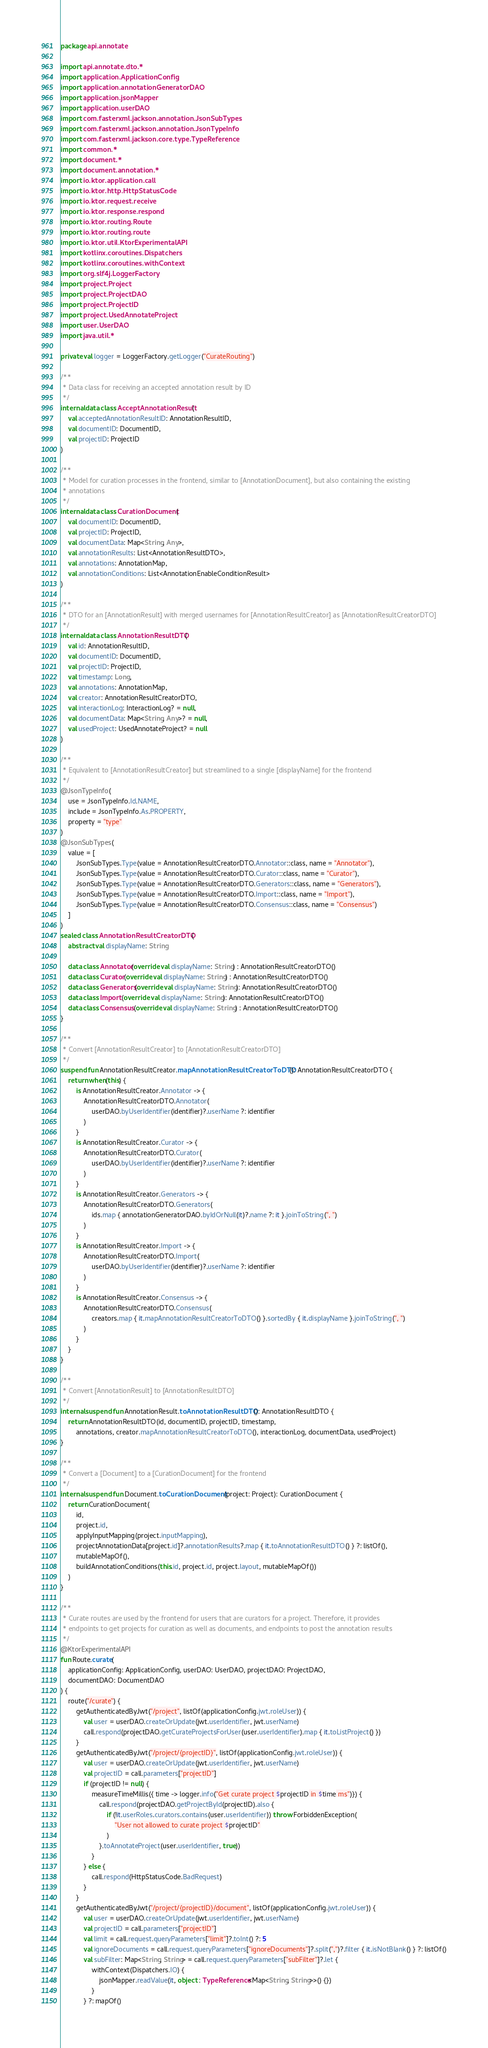<code> <loc_0><loc_0><loc_500><loc_500><_Kotlin_>package api.annotate

import api.annotate.dto.*
import application.ApplicationConfig
import application.annotationGeneratorDAO
import application.jsonMapper
import application.userDAO
import com.fasterxml.jackson.annotation.JsonSubTypes
import com.fasterxml.jackson.annotation.JsonTypeInfo
import com.fasterxml.jackson.core.type.TypeReference
import common.*
import document.*
import document.annotation.*
import io.ktor.application.call
import io.ktor.http.HttpStatusCode
import io.ktor.request.receive
import io.ktor.response.respond
import io.ktor.routing.Route
import io.ktor.routing.route
import io.ktor.util.KtorExperimentalAPI
import kotlinx.coroutines.Dispatchers
import kotlinx.coroutines.withContext
import org.slf4j.LoggerFactory
import project.Project
import project.ProjectDAO
import project.ProjectID
import project.UsedAnnotateProject
import user.UserDAO
import java.util.*

private val logger = LoggerFactory.getLogger("CurateRouting")

/**
 * Data class for receiving an accepted annotation result by ID
 */
internal data class AcceptAnnotationResult(
    val acceptedAnnotationResultID: AnnotationResultID,
    val documentID: DocumentID,
    val projectID: ProjectID
)

/**
 * Model for curation processes in the frontend, similar to [AnnotationDocument], but also containing the existing
 * annotations
 */
internal data class CurationDocument(
    val documentID: DocumentID,
    val projectID: ProjectID,
    val documentData: Map<String, Any>,
    val annotationResults: List<AnnotationResultDTO>,
    val annotations: AnnotationMap,
    val annotationConditions: List<AnnotationEnableConditionResult>
)

/**
 * DTO for an [AnnotationResult] with merged usernames for [AnnotationResultCreator] as [AnnotationResultCreatorDTO]
 */
internal data class AnnotationResultDTO(
    val id: AnnotationResultID,
    val documentID: DocumentID,
    val projectID: ProjectID,
    val timestamp: Long,
    val annotations: AnnotationMap,
    val creator: AnnotationResultCreatorDTO,
    val interactionLog: InteractionLog? = null,
    val documentData: Map<String, Any>? = null,
    val usedProject: UsedAnnotateProject? = null
)

/**
 * Equivalent to [AnnotationResultCreator] but streamlined to a single [displayName] for the frontend
 */
@JsonTypeInfo(
    use = JsonTypeInfo.Id.NAME,
    include = JsonTypeInfo.As.PROPERTY,
    property = "type"
)
@JsonSubTypes(
    value = [
        JsonSubTypes.Type(value = AnnotationResultCreatorDTO.Annotator::class, name = "Annotator"),
        JsonSubTypes.Type(value = AnnotationResultCreatorDTO.Curator::class, name = "Curator"),
        JsonSubTypes.Type(value = AnnotationResultCreatorDTO.Generators::class, name = "Generators"),
        JsonSubTypes.Type(value = AnnotationResultCreatorDTO.Import::class, name = "Import"),
        JsonSubTypes.Type(value = AnnotationResultCreatorDTO.Consensus::class, name = "Consensus")
    ]
)
sealed class AnnotationResultCreatorDTO {
    abstract val displayName: String

    data class Annotator(override val displayName: String) : AnnotationResultCreatorDTO()
    data class Curator(override val displayName: String) : AnnotationResultCreatorDTO()
    data class Generators(override val displayName: String): AnnotationResultCreatorDTO()
    data class Import(override val displayName: String): AnnotationResultCreatorDTO()
    data class Consensus(override val displayName: String) : AnnotationResultCreatorDTO()
}

/**
 * Convert [AnnotationResultCreator] to [AnnotationResultCreatorDTO]
 */
suspend fun AnnotationResultCreator.mapAnnotationResultCreatorToDTO(): AnnotationResultCreatorDTO {
    return when(this) {
        is AnnotationResultCreator.Annotator -> {
            AnnotationResultCreatorDTO.Annotator(
                userDAO.byUserIdentifier(identifier)?.userName ?: identifier
            )
        }
        is AnnotationResultCreator.Curator -> {
            AnnotationResultCreatorDTO.Curator(
                userDAO.byUserIdentifier(identifier)?.userName ?: identifier
            )
        }
        is AnnotationResultCreator.Generators -> {
            AnnotationResultCreatorDTO.Generators(
                ids.map { annotationGeneratorDAO.byIdOrNull(it)?.name ?: it }.joinToString(", ")
            )
        }
        is AnnotationResultCreator.Import -> {
            AnnotationResultCreatorDTO.Import(
                userDAO.byUserIdentifier(identifier)?.userName ?: identifier
            )
        }
        is AnnotationResultCreator.Consensus -> {
            AnnotationResultCreatorDTO.Consensus(
                creators.map { it.mapAnnotationResultCreatorToDTO() }.sortedBy { it.displayName }.joinToString(", ")
            )
        }
    }
}

/**
 * Convert [AnnotationResult] to [AnnotationResultDTO]
 */
internal suspend fun AnnotationResult.toAnnotationResultDTO(): AnnotationResultDTO {
    return AnnotationResultDTO(id, documentID, projectID, timestamp,
        annotations, creator.mapAnnotationResultCreatorToDTO(), interactionLog, documentData, usedProject)
}

/**
 * Convert a [Document] to a [CurationDocument] for the frontend
 */
internal suspend fun Document.toCurationDocument(project: Project): CurationDocument {
    return CurationDocument(
        id,
        project.id,
        applyInputMapping(project.inputMapping),
        projectAnnotationData[project.id]?.annotationResults?.map { it.toAnnotationResultDTO() } ?: listOf(),
        mutableMapOf(),
        buildAnnotationConditions(this.id, project.id, project.layout, mutableMapOf())
    )
}

/**
 * Curate routes are used by the frontend for users that are curators for a project. Therefore, it provides
 * endpoints to get projects for curation as well as documents, and endpoints to post the annotation results
 */
@KtorExperimentalAPI
fun Route.curate(
    applicationConfig: ApplicationConfig, userDAO: UserDAO, projectDAO: ProjectDAO,
    documentDAO: DocumentDAO
) {
    route("/curate") {
        getAuthenticatedByJwt("/project", listOf(applicationConfig.jwt.roleUser)) {
            val user = userDAO.createOrUpdate(jwt.userIdentifier, jwt.userName)
            call.respond(projectDAO.getCurateProjectsForUser(user.userIdentifier).map { it.toListProject() })
        }
        getAuthenticatedByJwt("/project/{projectID}", listOf(applicationConfig.jwt.roleUser)) {
            val user = userDAO.createOrUpdate(jwt.userIdentifier, jwt.userName)
            val projectID = call.parameters["projectID"]
            if (projectID != null) {
                measureTimeMillis({ time -> logger.info("Get curate project $projectID in $time ms")}) {
                    call.respond(projectDAO.getProjectById(projectID).also {
                        if (!it.userRoles.curators.contains(user.userIdentifier)) throw ForbiddenException(
                            "User not allowed to curate project $projectID"
                        )
                    }.toAnnotateProject(user.userIdentifier, true))
                }
            } else {
                call.respond(HttpStatusCode.BadRequest)
            }
        }
        getAuthenticatedByJwt("/project/{projectID}/document", listOf(applicationConfig.jwt.roleUser)) {
            val user = userDAO.createOrUpdate(jwt.userIdentifier, jwt.userName)
            val projectID = call.parameters["projectID"]
            val limit = call.request.queryParameters["limit"]?.toInt() ?: 5
            val ignoreDocuments = call.request.queryParameters["ignoreDocuments"]?.split(",")?.filter { it.isNotBlank() } ?: listOf()
            val subFilter: Map<String, String> = call.request.queryParameters["subFilter"]?.let {
                withContext(Dispatchers.IO) {
                    jsonMapper.readValue(it, object : TypeReference<Map<String, String>>() {})
                }
            } ?: mapOf()</code> 